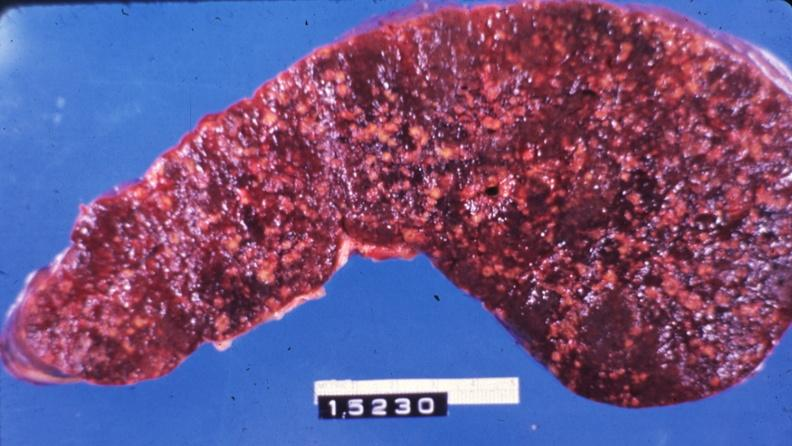s rheumatoid arthritis present?
Answer the question using a single word or phrase. No 